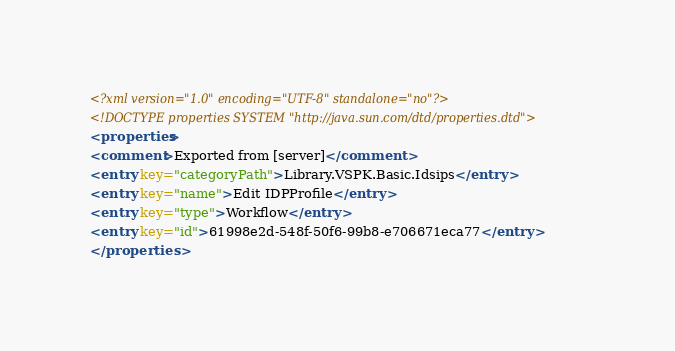<code> <loc_0><loc_0><loc_500><loc_500><_XML_><?xml version="1.0" encoding="UTF-8" standalone="no"?>
<!DOCTYPE properties SYSTEM "http://java.sun.com/dtd/properties.dtd">
<properties>
<comment>Exported from [server]</comment>
<entry key="categoryPath">Library.VSPK.Basic.Idsips</entry>
<entry key="name">Edit IDPProfile</entry>
<entry key="type">Workflow</entry>
<entry key="id">61998e2d-548f-50f6-99b8-e706671eca77</entry>
</properties></code> 